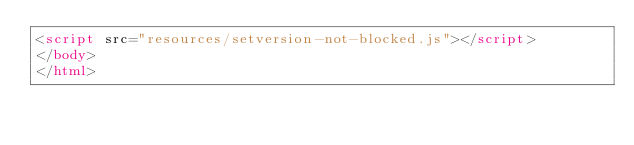Convert code to text. <code><loc_0><loc_0><loc_500><loc_500><_HTML_><script src="resources/setversion-not-blocked.js"></script>
</body>
</html>
</code> 